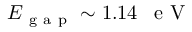Convert formula to latex. <formula><loc_0><loc_0><loc_500><loc_500>E _ { g a p } \sim 1 . 1 4 \, e V</formula> 